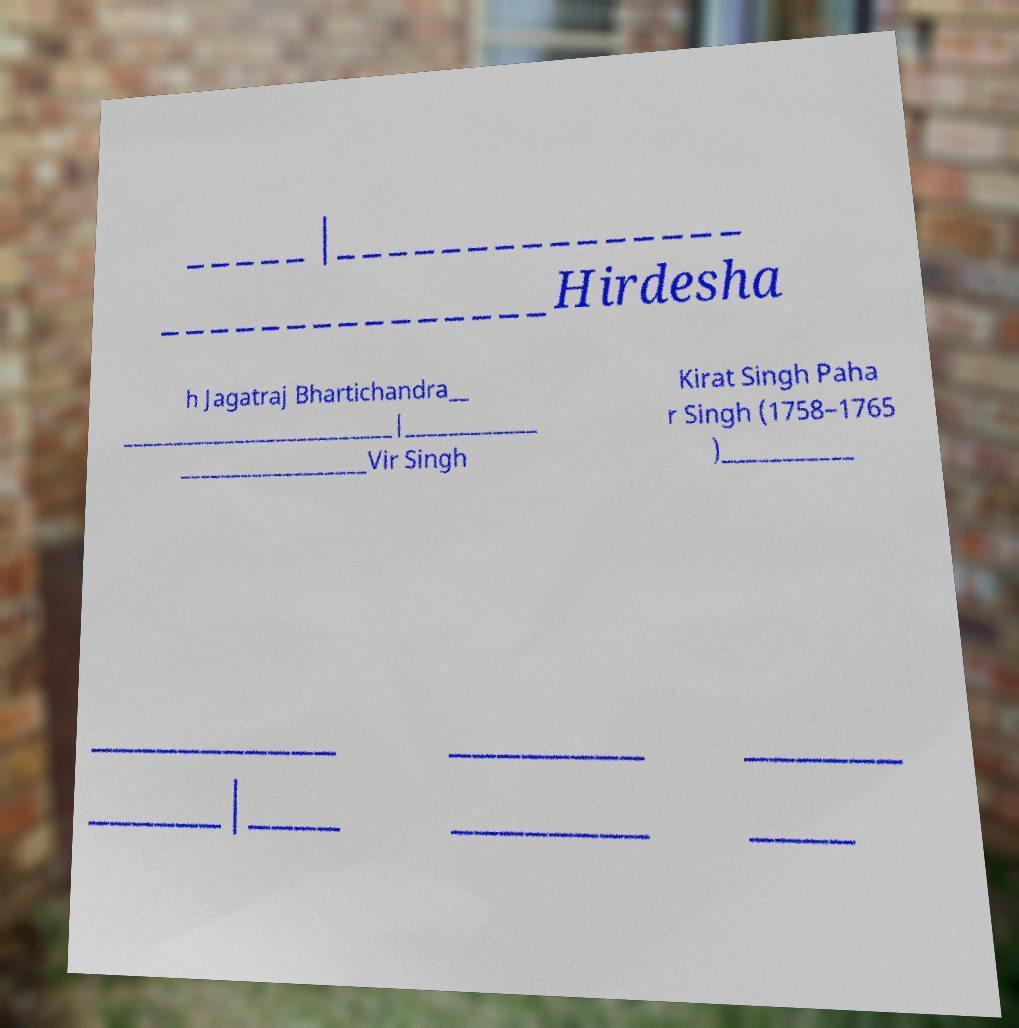Could you assist in decoding the text presented in this image and type it out clearly? _____|_______________ _______________Hirdesha h Jagatraj Bhartichandra__ __________________________|____________ __________________Vir Singh Kirat Singh Paha r Singh (1758–1765 )___________ ___________ ______|____ ________ ________ ______ ____ 